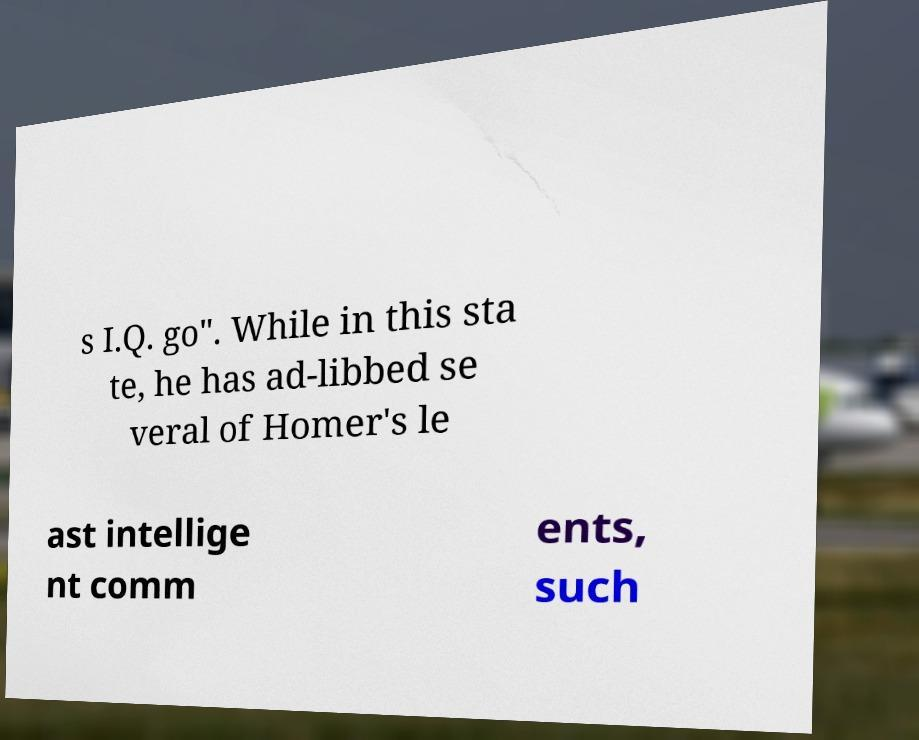For documentation purposes, I need the text within this image transcribed. Could you provide that? s I.Q. go". While in this sta te, he has ad-libbed se veral of Homer's le ast intellige nt comm ents, such 